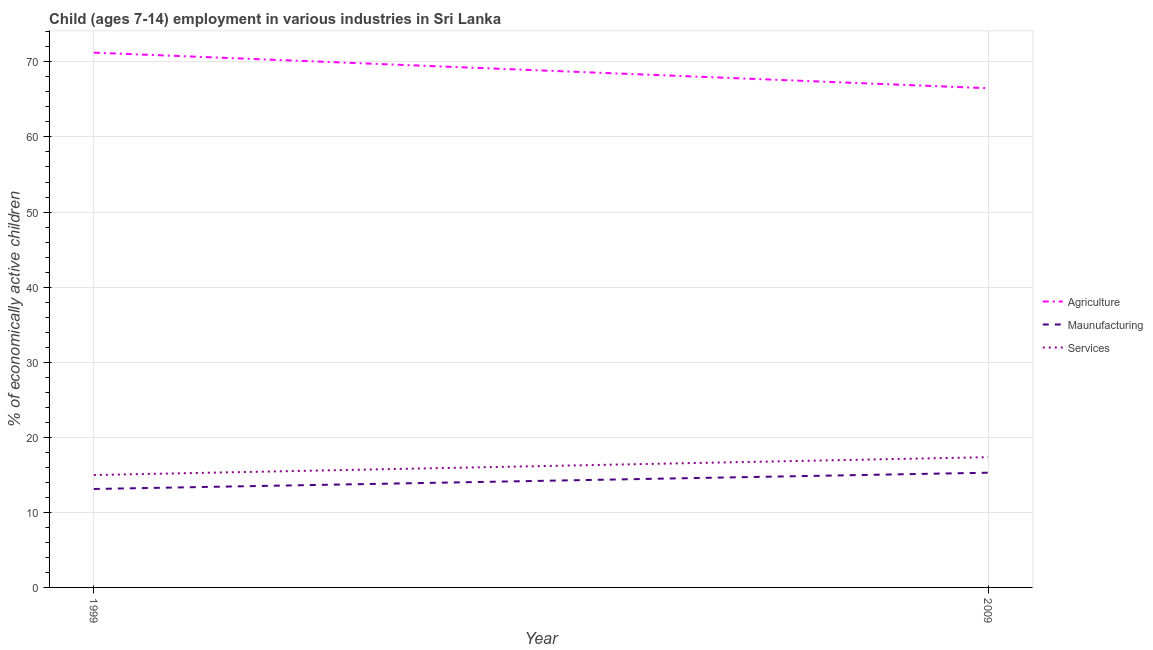How many different coloured lines are there?
Your response must be concise. 3. Does the line corresponding to percentage of economically active children in agriculture intersect with the line corresponding to percentage of economically active children in manufacturing?
Your response must be concise. No. What is the percentage of economically active children in manufacturing in 2009?
Ensure brevity in your answer.  15.28. Across all years, what is the maximum percentage of economically active children in services?
Keep it short and to the point. 17.35. Across all years, what is the minimum percentage of economically active children in manufacturing?
Offer a terse response. 13.11. In which year was the percentage of economically active children in manufacturing maximum?
Give a very brief answer. 2009. What is the total percentage of economically active children in agriculture in the graph?
Offer a very short reply. 137.72. What is the difference between the percentage of economically active children in agriculture in 1999 and that in 2009?
Your response must be concise. 4.74. What is the difference between the percentage of economically active children in manufacturing in 1999 and the percentage of economically active children in services in 2009?
Offer a very short reply. -4.24. What is the average percentage of economically active children in agriculture per year?
Give a very brief answer. 68.86. In the year 2009, what is the difference between the percentage of economically active children in agriculture and percentage of economically active children in manufacturing?
Make the answer very short. 51.21. In how many years, is the percentage of economically active children in services greater than 26 %?
Your response must be concise. 0. What is the ratio of the percentage of economically active children in manufacturing in 1999 to that in 2009?
Make the answer very short. 0.86. Is the percentage of economically active children in manufacturing in 1999 less than that in 2009?
Give a very brief answer. Yes. In how many years, is the percentage of economically active children in manufacturing greater than the average percentage of economically active children in manufacturing taken over all years?
Offer a terse response. 1. Does the percentage of economically active children in manufacturing monotonically increase over the years?
Offer a very short reply. Yes. Is the percentage of economically active children in agriculture strictly greater than the percentage of economically active children in services over the years?
Offer a very short reply. Yes. Does the graph contain grids?
Ensure brevity in your answer.  Yes. Where does the legend appear in the graph?
Your response must be concise. Center right. How are the legend labels stacked?
Your answer should be compact. Vertical. What is the title of the graph?
Give a very brief answer. Child (ages 7-14) employment in various industries in Sri Lanka. What is the label or title of the X-axis?
Offer a very short reply. Year. What is the label or title of the Y-axis?
Provide a short and direct response. % of economically active children. What is the % of economically active children of Agriculture in 1999?
Provide a short and direct response. 71.23. What is the % of economically active children of Maunufacturing in 1999?
Ensure brevity in your answer.  13.11. What is the % of economically active children of Services in 1999?
Provide a short and direct response. 14.97. What is the % of economically active children in Agriculture in 2009?
Make the answer very short. 66.49. What is the % of economically active children in Maunufacturing in 2009?
Offer a terse response. 15.28. What is the % of economically active children of Services in 2009?
Your answer should be compact. 17.35. Across all years, what is the maximum % of economically active children in Agriculture?
Provide a succinct answer. 71.23. Across all years, what is the maximum % of economically active children of Maunufacturing?
Your answer should be compact. 15.28. Across all years, what is the maximum % of economically active children of Services?
Provide a short and direct response. 17.35. Across all years, what is the minimum % of economically active children of Agriculture?
Provide a short and direct response. 66.49. Across all years, what is the minimum % of economically active children of Maunufacturing?
Your answer should be compact. 13.11. Across all years, what is the minimum % of economically active children in Services?
Your response must be concise. 14.97. What is the total % of economically active children of Agriculture in the graph?
Your answer should be very brief. 137.72. What is the total % of economically active children of Maunufacturing in the graph?
Offer a very short reply. 28.39. What is the total % of economically active children of Services in the graph?
Give a very brief answer. 32.32. What is the difference between the % of economically active children in Agriculture in 1999 and that in 2009?
Offer a terse response. 4.74. What is the difference between the % of economically active children of Maunufacturing in 1999 and that in 2009?
Provide a succinct answer. -2.17. What is the difference between the % of economically active children in Services in 1999 and that in 2009?
Ensure brevity in your answer.  -2.38. What is the difference between the % of economically active children of Agriculture in 1999 and the % of economically active children of Maunufacturing in 2009?
Provide a short and direct response. 55.95. What is the difference between the % of economically active children of Agriculture in 1999 and the % of economically active children of Services in 2009?
Give a very brief answer. 53.88. What is the difference between the % of economically active children of Maunufacturing in 1999 and the % of economically active children of Services in 2009?
Offer a terse response. -4.24. What is the average % of economically active children in Agriculture per year?
Your response must be concise. 68.86. What is the average % of economically active children of Maunufacturing per year?
Offer a terse response. 14.2. What is the average % of economically active children of Services per year?
Offer a terse response. 16.16. In the year 1999, what is the difference between the % of economically active children of Agriculture and % of economically active children of Maunufacturing?
Your response must be concise. 58.12. In the year 1999, what is the difference between the % of economically active children of Agriculture and % of economically active children of Services?
Ensure brevity in your answer.  56.26. In the year 1999, what is the difference between the % of economically active children of Maunufacturing and % of economically active children of Services?
Ensure brevity in your answer.  -1.86. In the year 2009, what is the difference between the % of economically active children of Agriculture and % of economically active children of Maunufacturing?
Provide a succinct answer. 51.21. In the year 2009, what is the difference between the % of economically active children in Agriculture and % of economically active children in Services?
Keep it short and to the point. 49.14. In the year 2009, what is the difference between the % of economically active children in Maunufacturing and % of economically active children in Services?
Your answer should be compact. -2.07. What is the ratio of the % of economically active children of Agriculture in 1999 to that in 2009?
Offer a terse response. 1.07. What is the ratio of the % of economically active children in Maunufacturing in 1999 to that in 2009?
Give a very brief answer. 0.86. What is the ratio of the % of economically active children of Services in 1999 to that in 2009?
Ensure brevity in your answer.  0.86. What is the difference between the highest and the second highest % of economically active children of Agriculture?
Provide a succinct answer. 4.74. What is the difference between the highest and the second highest % of economically active children in Maunufacturing?
Your answer should be compact. 2.17. What is the difference between the highest and the second highest % of economically active children in Services?
Give a very brief answer. 2.38. What is the difference between the highest and the lowest % of economically active children in Agriculture?
Provide a succinct answer. 4.74. What is the difference between the highest and the lowest % of economically active children of Maunufacturing?
Your response must be concise. 2.17. What is the difference between the highest and the lowest % of economically active children of Services?
Your answer should be compact. 2.38. 